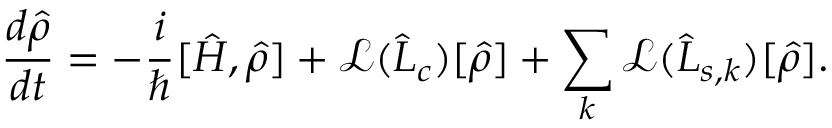Convert formula to latex. <formula><loc_0><loc_0><loc_500><loc_500>\frac { d \hat { \rho } } { d t } = - \frac { i } { } [ \hat { H } , \hat { \rho } ] + \mathcal { L } ( \hat { L } _ { c } ) [ \hat { \rho } ] + \sum _ { k } \mathcal { L } ( \hat { L } _ { s , k } ) [ \hat { \rho } ] .</formula> 